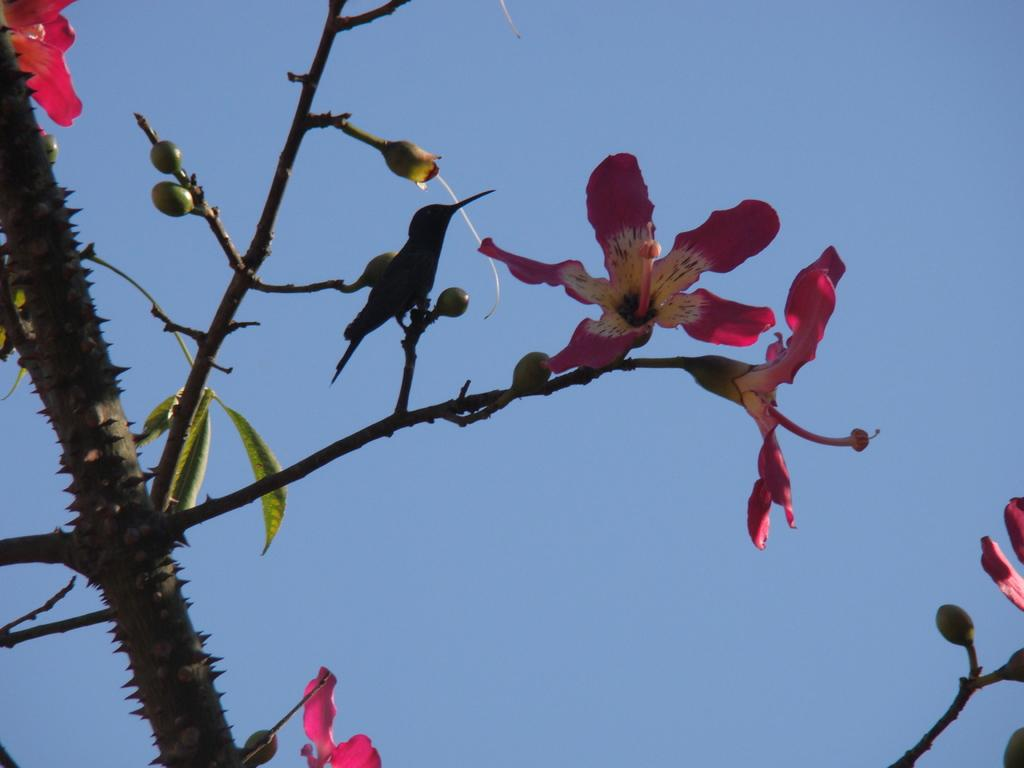What is located in the foreground of the image? There is a tree in the foreground of the image. What can be seen near the tree? There are flowers near the tree. What type of animal is on the tree? There is a bird on the tree. What is visible in the background of the image? The sky is visible in the background of the image. What type of operation is being performed on the children in the image? There are no children or operations present in the image; it features a tree, flowers, and a bird. What type of plantation is visible in the image? There is no plantation present in the image; it features a tree, flowers, and a bird. 